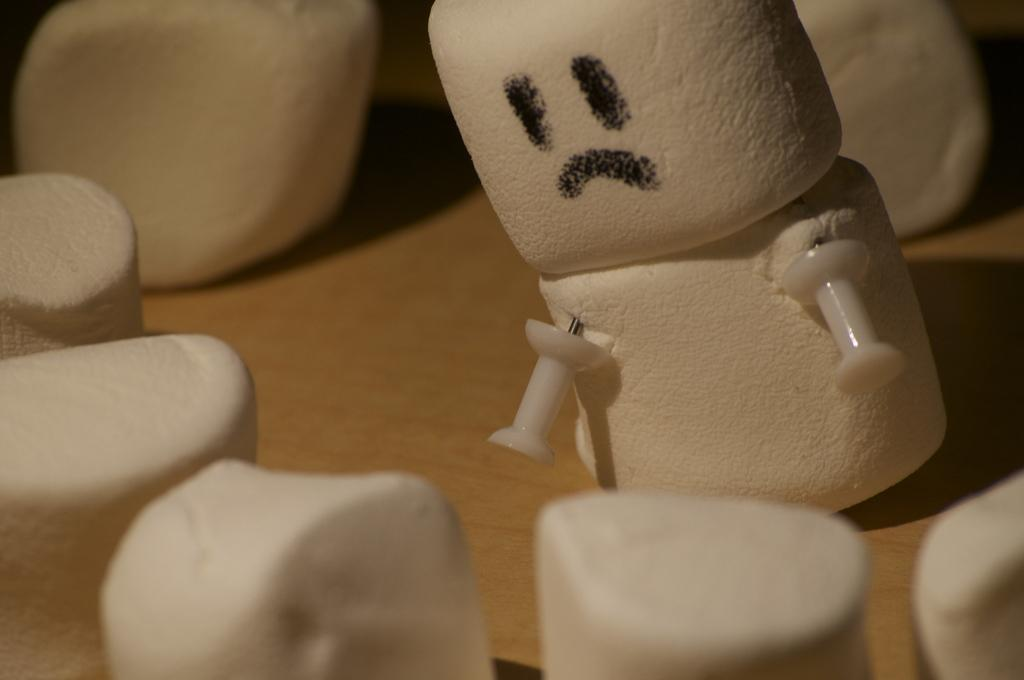What type of food can be seen on the table in the image? There are marshmallows on the table in the image. What is the color of the marshmallows? The marshmallows are white in color. What other objects can be seen in the image besides the marshmallows? There are two yo-yo pins in the image. What type of carriage is visible in the image? There is no carriage present in the image. What type of sponge is used to clean the marshmallows in the image? There is no sponge or cleaning activity involving the marshmallows in the image. 